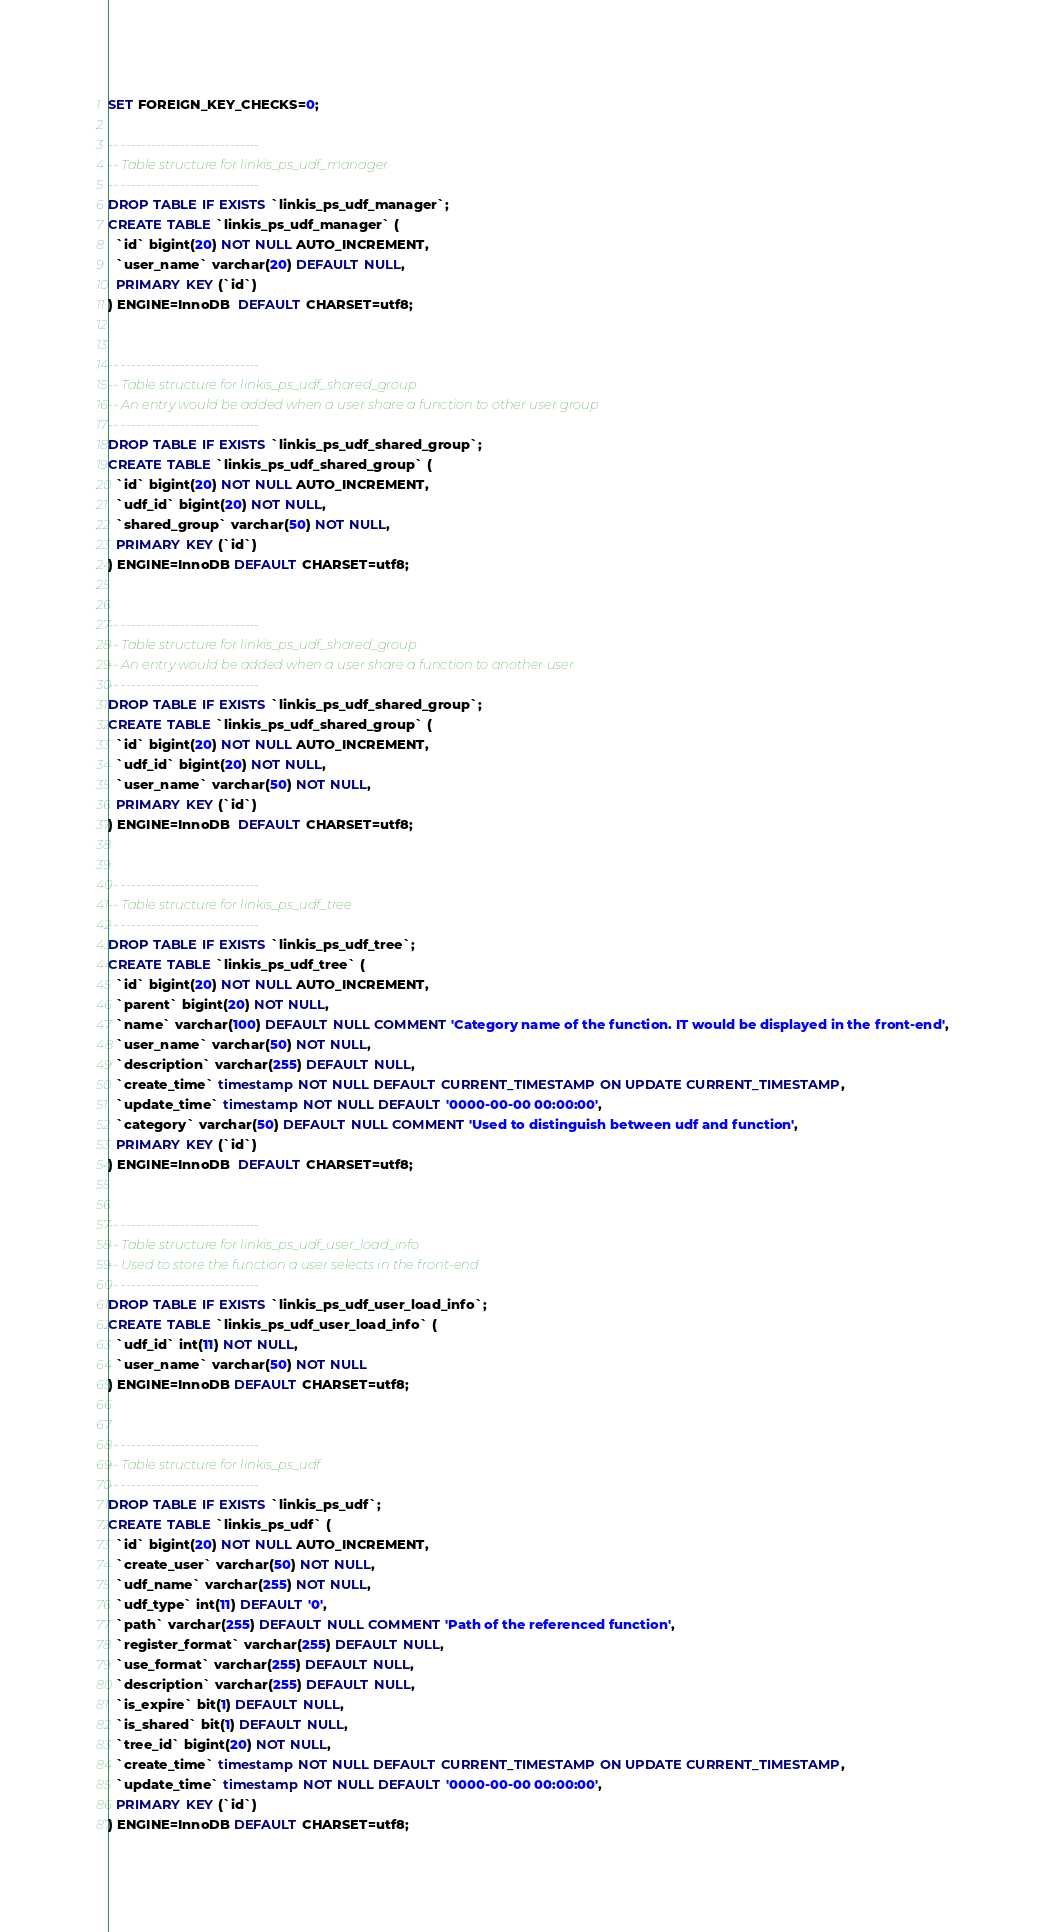Convert code to text. <code><loc_0><loc_0><loc_500><loc_500><_SQL_>SET FOREIGN_KEY_CHECKS=0;

-- ----------------------------
-- Table structure for linkis_ps_udf_manager
-- ----------------------------
DROP TABLE IF EXISTS `linkis_ps_udf_manager`;
CREATE TABLE `linkis_ps_udf_manager` (
  `id` bigint(20) NOT NULL AUTO_INCREMENT,
  `user_name` varchar(20) DEFAULT NULL,
  PRIMARY KEY (`id`)
) ENGINE=InnoDB  DEFAULT CHARSET=utf8;


-- ----------------------------
-- Table structure for linkis_ps_udf_shared_group
-- An entry would be added when a user share a function to other user group
-- ----------------------------
DROP TABLE IF EXISTS `linkis_ps_udf_shared_group`;
CREATE TABLE `linkis_ps_udf_shared_group` (
  `id` bigint(20) NOT NULL AUTO_INCREMENT,
  `udf_id` bigint(20) NOT NULL,
  `shared_group` varchar(50) NOT NULL,
  PRIMARY KEY (`id`)
) ENGINE=InnoDB DEFAULT CHARSET=utf8;


-- ----------------------------
-- Table structure for linkis_ps_udf_shared_group
-- An entry would be added when a user share a function to another user
-- ----------------------------
DROP TABLE IF EXISTS `linkis_ps_udf_shared_group`;
CREATE TABLE `linkis_ps_udf_shared_group` (
  `id` bigint(20) NOT NULL AUTO_INCREMENT,
  `udf_id` bigint(20) NOT NULL,
  `user_name` varchar(50) NOT NULL,
  PRIMARY KEY (`id`)
) ENGINE=InnoDB  DEFAULT CHARSET=utf8;


-- ----------------------------
-- Table structure for linkis_ps_udf_tree
-- ----------------------------
DROP TABLE IF EXISTS `linkis_ps_udf_tree`;
CREATE TABLE `linkis_ps_udf_tree` (
  `id` bigint(20) NOT NULL AUTO_INCREMENT,
  `parent` bigint(20) NOT NULL,
  `name` varchar(100) DEFAULT NULL COMMENT 'Category name of the function. IT would be displayed in the front-end',
  `user_name` varchar(50) NOT NULL,
  `description` varchar(255) DEFAULT NULL,
  `create_time` timestamp NOT NULL DEFAULT CURRENT_TIMESTAMP ON UPDATE CURRENT_TIMESTAMP,
  `update_time` timestamp NOT NULL DEFAULT '0000-00-00 00:00:00',
  `category` varchar(50) DEFAULT NULL COMMENT 'Used to distinguish between udf and function',
  PRIMARY KEY (`id`)
) ENGINE=InnoDB  DEFAULT CHARSET=utf8;


-- ----------------------------
-- Table structure for linkis_ps_udf_user_load_info
-- Used to store the function a user selects in the front-end
-- ----------------------------
DROP TABLE IF EXISTS `linkis_ps_udf_user_load_info`;
CREATE TABLE `linkis_ps_udf_user_load_info` (
  `udf_id` int(11) NOT NULL,
  `user_name` varchar(50) NOT NULL
) ENGINE=InnoDB DEFAULT CHARSET=utf8;


-- ----------------------------
-- Table structure for linkis_ps_udf
-- ----------------------------
DROP TABLE IF EXISTS `linkis_ps_udf`;
CREATE TABLE `linkis_ps_udf` (
  `id` bigint(20) NOT NULL AUTO_INCREMENT,
  `create_user` varchar(50) NOT NULL,
  `udf_name` varchar(255) NOT NULL,
  `udf_type` int(11) DEFAULT '0',
  `path` varchar(255) DEFAULT NULL COMMENT 'Path of the referenced function',
  `register_format` varchar(255) DEFAULT NULL,
  `use_format` varchar(255) DEFAULT NULL,
  `description` varchar(255) DEFAULT NULL,
  `is_expire` bit(1) DEFAULT NULL,
  `is_shared` bit(1) DEFAULT NULL,
  `tree_id` bigint(20) NOT NULL,
  `create_time` timestamp NOT NULL DEFAULT CURRENT_TIMESTAMP ON UPDATE CURRENT_TIMESTAMP,
  `update_time` timestamp NOT NULL DEFAULT '0000-00-00 00:00:00',
  PRIMARY KEY (`id`)
) ENGINE=InnoDB DEFAULT CHARSET=utf8;
</code> 